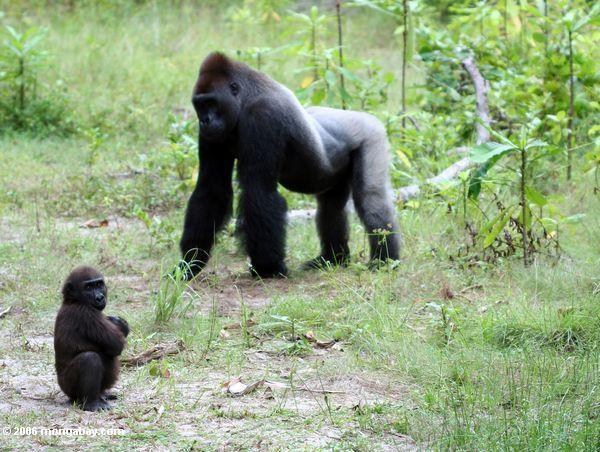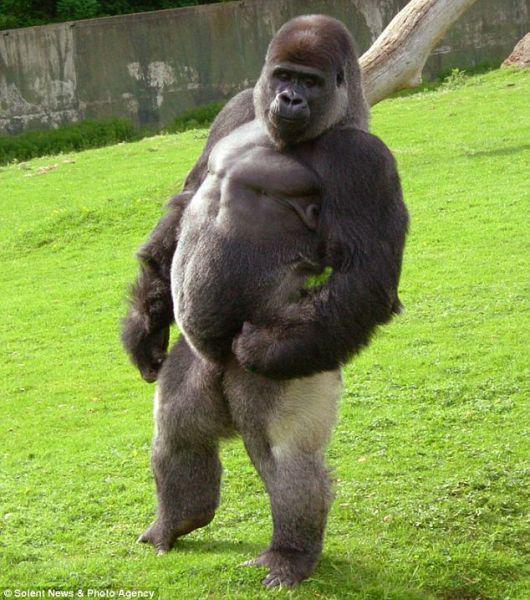The first image is the image on the left, the second image is the image on the right. For the images displayed, is the sentence "Two gorillas are bent forward, standing on all four feet." factually correct? Answer yes or no. No. The first image is the image on the left, the second image is the image on the right. Analyze the images presented: Is the assertion "All images show a gorilla standing on its legs and hands." valid? Answer yes or no. No. 